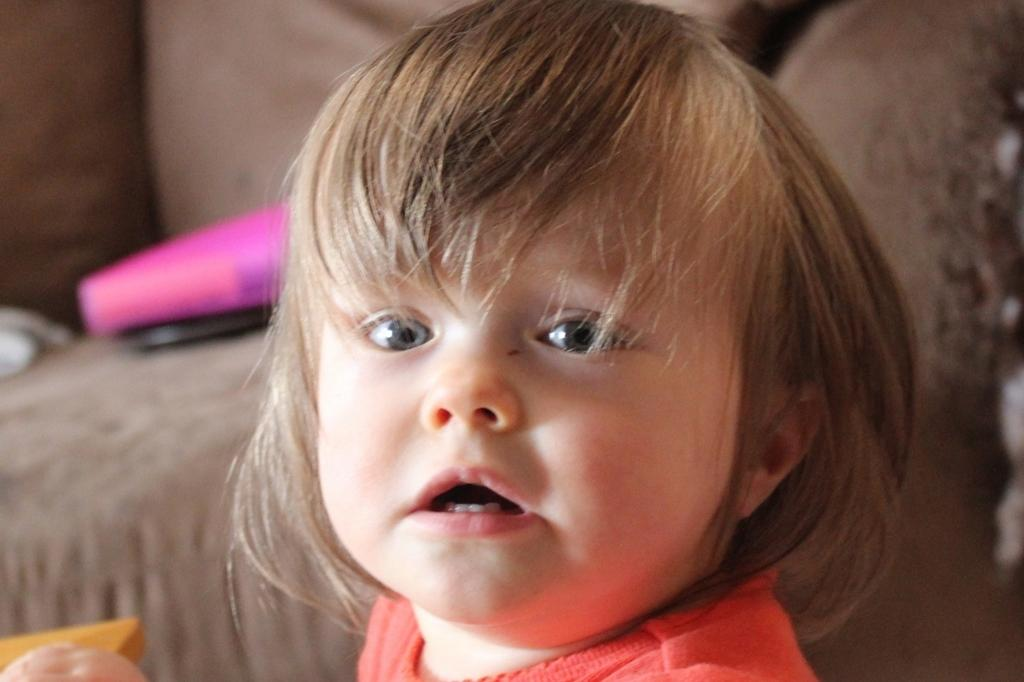What is the main subject of the image? The main subject of the image is a kid. What is the kid doing in the image? The kid is watching something. Can you describe the background of the image? The background of the image is blurred. Are there any other objects or elements in the image besides the kid? Yes, there are objects present in the image. What type of farming equipment can be seen in the image? There is no farming equipment present in the image. What kind of art is the kid creating in the image? The image does not show the kid creating any art. 